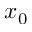<formula> <loc_0><loc_0><loc_500><loc_500>x _ { 0 }</formula> 